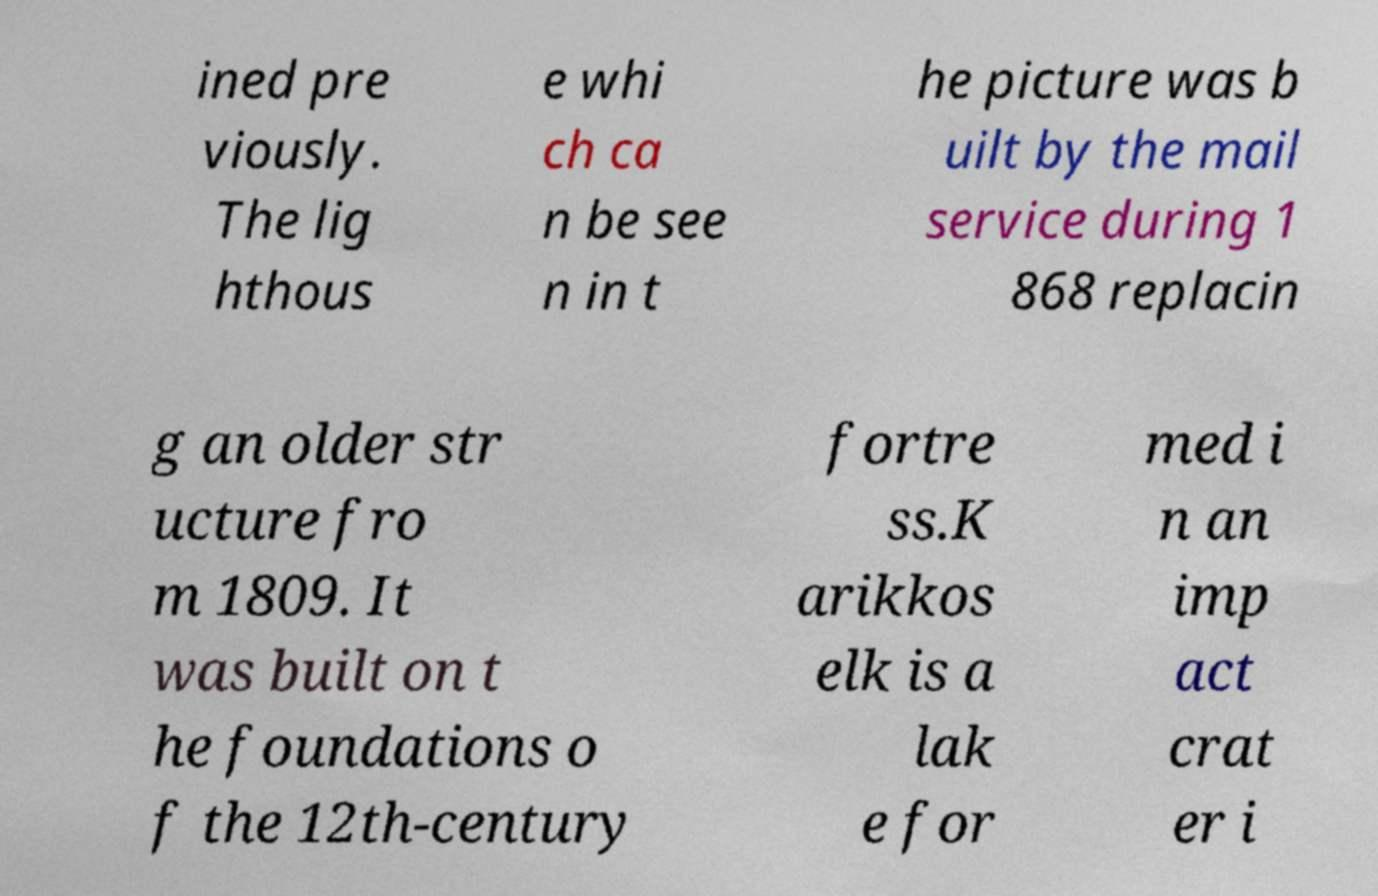Can you accurately transcribe the text from the provided image for me? ined pre viously. The lig hthous e whi ch ca n be see n in t he picture was b uilt by the mail service during 1 868 replacin g an older str ucture fro m 1809. It was built on t he foundations o f the 12th-century fortre ss.K arikkos elk is a lak e for med i n an imp act crat er i 